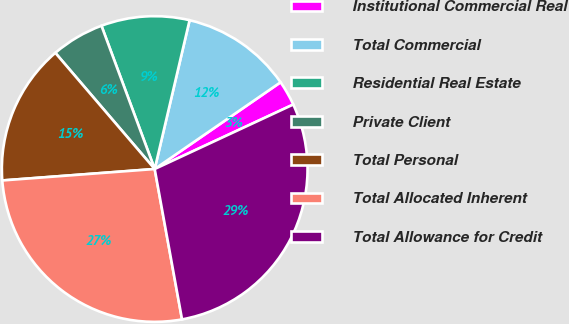Convert chart to OTSL. <chart><loc_0><loc_0><loc_500><loc_500><pie_chart><fcel>Institutional Commercial Real<fcel>Total Commercial<fcel>Residential Real Estate<fcel>Private Client<fcel>Total Personal<fcel>Total Allocated Inherent<fcel>Total Allowance for Credit<nl><fcel>2.67%<fcel>11.73%<fcel>9.33%<fcel>5.6%<fcel>14.93%<fcel>26.67%<fcel>29.07%<nl></chart> 